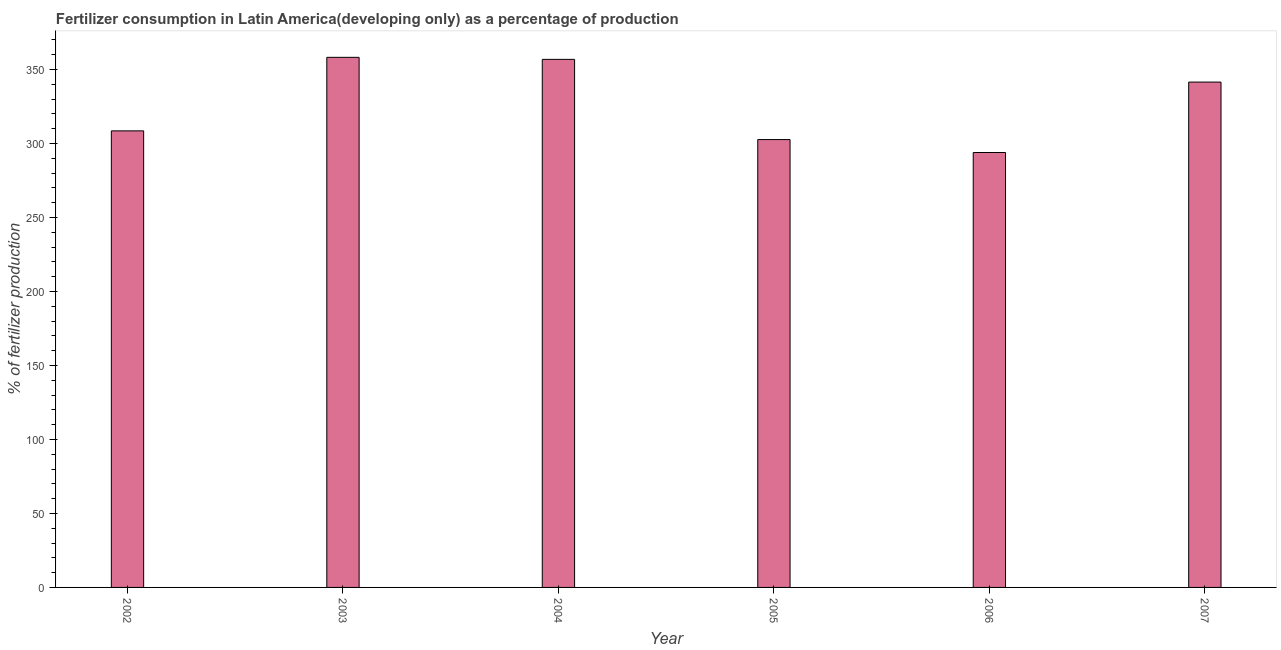Does the graph contain any zero values?
Make the answer very short. No. Does the graph contain grids?
Keep it short and to the point. No. What is the title of the graph?
Offer a very short reply. Fertilizer consumption in Latin America(developing only) as a percentage of production. What is the label or title of the X-axis?
Keep it short and to the point. Year. What is the label or title of the Y-axis?
Your response must be concise. % of fertilizer production. What is the amount of fertilizer consumption in 2003?
Your answer should be compact. 358.28. Across all years, what is the maximum amount of fertilizer consumption?
Offer a very short reply. 358.28. Across all years, what is the minimum amount of fertilizer consumption?
Give a very brief answer. 293.95. In which year was the amount of fertilizer consumption minimum?
Make the answer very short. 2006. What is the sum of the amount of fertilizer consumption?
Provide a succinct answer. 1961.97. What is the difference between the amount of fertilizer consumption in 2004 and 2006?
Give a very brief answer. 62.96. What is the average amount of fertilizer consumption per year?
Make the answer very short. 327. What is the median amount of fertilizer consumption?
Your answer should be compact. 325.07. In how many years, is the amount of fertilizer consumption greater than 160 %?
Offer a very short reply. 6. What is the ratio of the amount of fertilizer consumption in 2003 to that in 2007?
Make the answer very short. 1.05. Is the amount of fertilizer consumption in 2002 less than that in 2004?
Offer a very short reply. Yes. What is the difference between the highest and the second highest amount of fertilizer consumption?
Offer a terse response. 1.38. Is the sum of the amount of fertilizer consumption in 2003 and 2005 greater than the maximum amount of fertilizer consumption across all years?
Ensure brevity in your answer.  Yes. What is the difference between the highest and the lowest amount of fertilizer consumption?
Make the answer very short. 64.33. Are all the bars in the graph horizontal?
Make the answer very short. No. What is the difference between two consecutive major ticks on the Y-axis?
Your answer should be compact. 50. Are the values on the major ticks of Y-axis written in scientific E-notation?
Your response must be concise. No. What is the % of fertilizer production of 2002?
Make the answer very short. 308.58. What is the % of fertilizer production in 2003?
Keep it short and to the point. 358.28. What is the % of fertilizer production of 2004?
Your response must be concise. 356.91. What is the % of fertilizer production of 2005?
Your answer should be compact. 302.7. What is the % of fertilizer production in 2006?
Offer a terse response. 293.95. What is the % of fertilizer production in 2007?
Offer a very short reply. 341.55. What is the difference between the % of fertilizer production in 2002 and 2003?
Your answer should be very brief. -49.71. What is the difference between the % of fertilizer production in 2002 and 2004?
Your answer should be very brief. -48.33. What is the difference between the % of fertilizer production in 2002 and 2005?
Your answer should be very brief. 5.88. What is the difference between the % of fertilizer production in 2002 and 2006?
Ensure brevity in your answer.  14.63. What is the difference between the % of fertilizer production in 2002 and 2007?
Ensure brevity in your answer.  -32.98. What is the difference between the % of fertilizer production in 2003 and 2004?
Your answer should be compact. 1.38. What is the difference between the % of fertilizer production in 2003 and 2005?
Your response must be concise. 55.58. What is the difference between the % of fertilizer production in 2003 and 2006?
Your answer should be very brief. 64.33. What is the difference between the % of fertilizer production in 2003 and 2007?
Your answer should be compact. 16.73. What is the difference between the % of fertilizer production in 2004 and 2005?
Make the answer very short. 54.21. What is the difference between the % of fertilizer production in 2004 and 2006?
Provide a succinct answer. 62.96. What is the difference between the % of fertilizer production in 2004 and 2007?
Provide a succinct answer. 15.35. What is the difference between the % of fertilizer production in 2005 and 2006?
Keep it short and to the point. 8.75. What is the difference between the % of fertilizer production in 2005 and 2007?
Give a very brief answer. -38.85. What is the difference between the % of fertilizer production in 2006 and 2007?
Provide a short and direct response. -47.6. What is the ratio of the % of fertilizer production in 2002 to that in 2003?
Your response must be concise. 0.86. What is the ratio of the % of fertilizer production in 2002 to that in 2004?
Give a very brief answer. 0.86. What is the ratio of the % of fertilizer production in 2002 to that in 2007?
Give a very brief answer. 0.9. What is the ratio of the % of fertilizer production in 2003 to that in 2005?
Ensure brevity in your answer.  1.18. What is the ratio of the % of fertilizer production in 2003 to that in 2006?
Ensure brevity in your answer.  1.22. What is the ratio of the % of fertilizer production in 2003 to that in 2007?
Make the answer very short. 1.05. What is the ratio of the % of fertilizer production in 2004 to that in 2005?
Provide a short and direct response. 1.18. What is the ratio of the % of fertilizer production in 2004 to that in 2006?
Your answer should be very brief. 1.21. What is the ratio of the % of fertilizer production in 2004 to that in 2007?
Make the answer very short. 1.04. What is the ratio of the % of fertilizer production in 2005 to that in 2007?
Your response must be concise. 0.89. What is the ratio of the % of fertilizer production in 2006 to that in 2007?
Your answer should be compact. 0.86. 